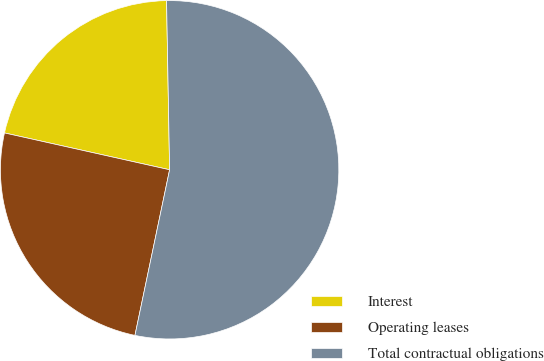Convert chart to OTSL. <chart><loc_0><loc_0><loc_500><loc_500><pie_chart><fcel>Interest<fcel>Operating leases<fcel>Total contractual obligations<nl><fcel>21.22%<fcel>25.21%<fcel>53.57%<nl></chart> 